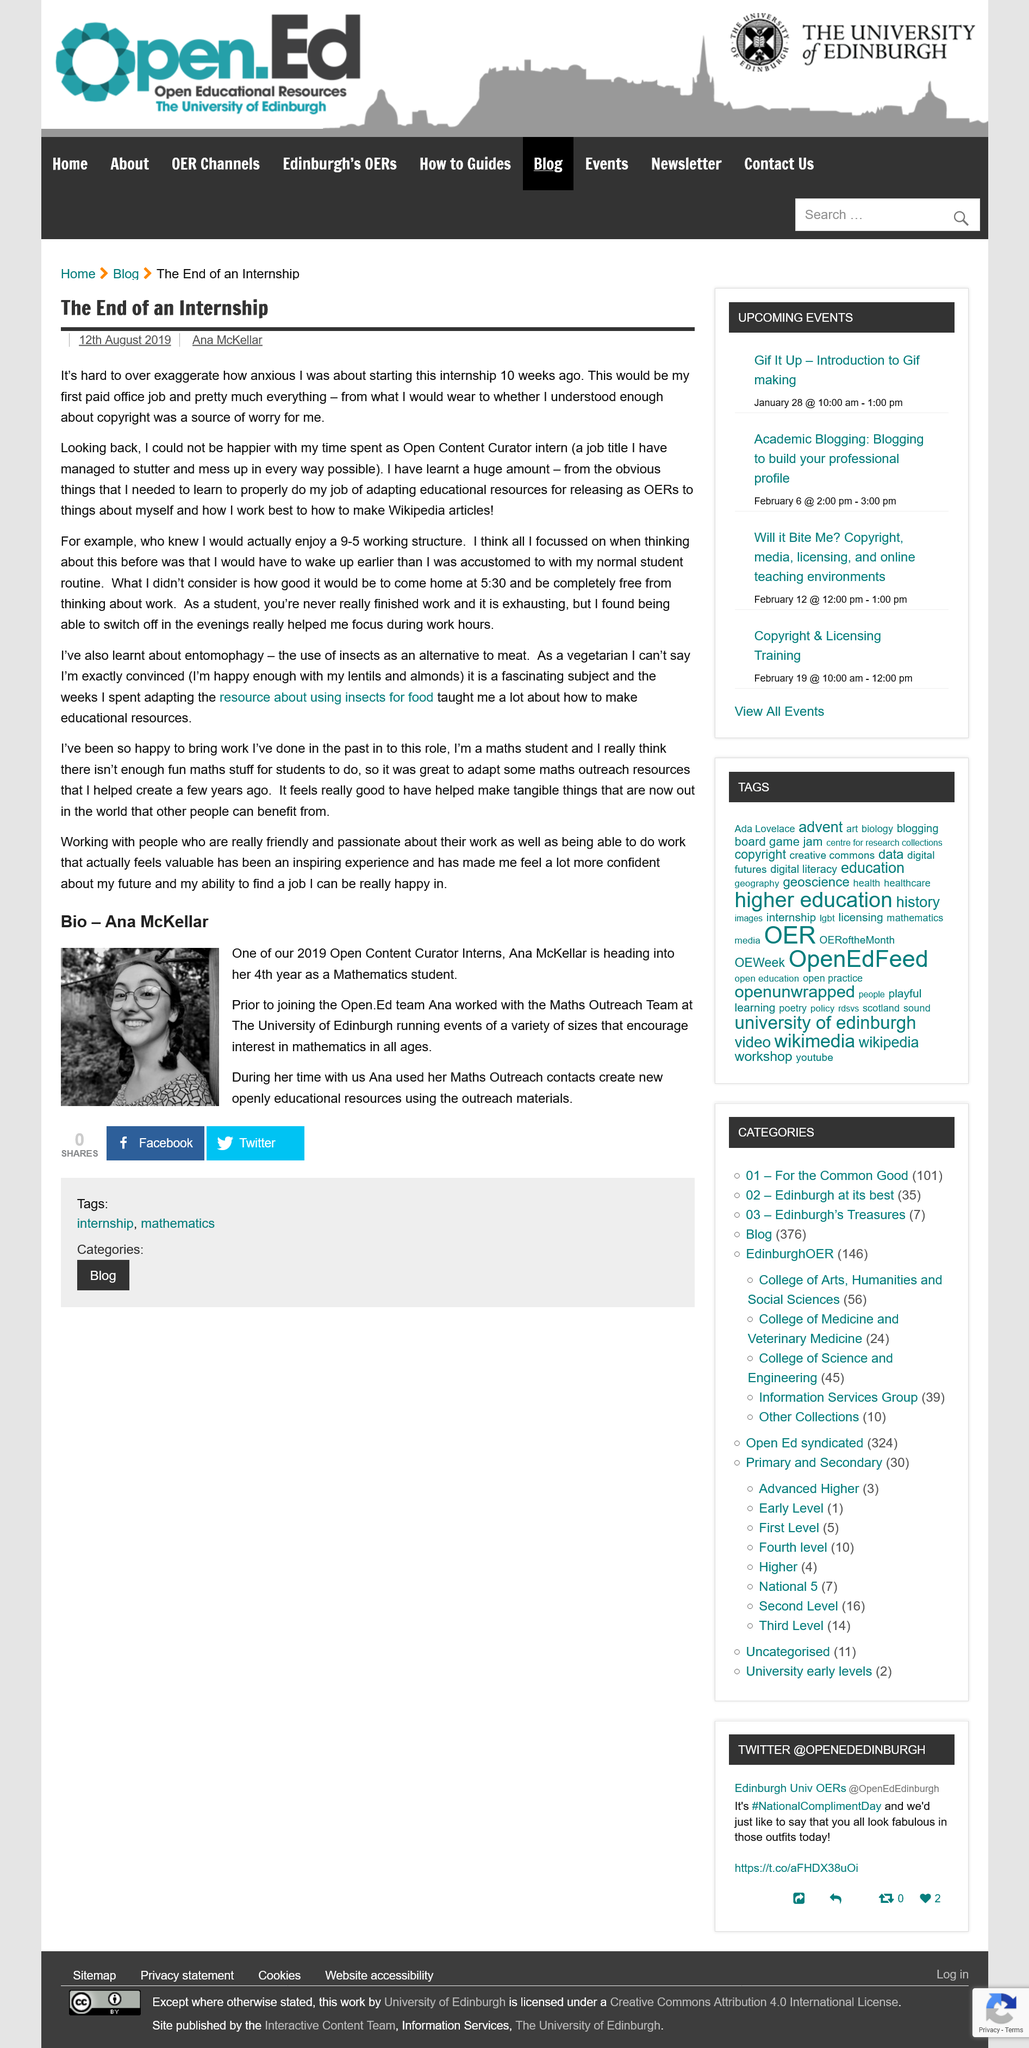Identify some key points in this picture. Ana is a 2019 Open Content Curator Intern. According to the article, entomophagy refers to the consumption of insects as a substitute for traditional meat sources. The job title of the role performed by the intern was "Open Content Curator intern. Ana McKellar, as stated in her biography, is a student of Mathematics. Ana McKellar collaborated with the Maths Outreach Team at the University of Edinburgh. 